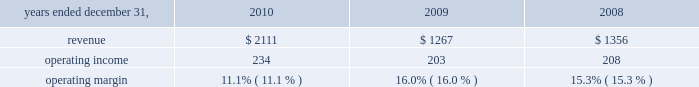Hr solutions .
In october 2010 , we completed the acquisition of hewitt , one of the world 2019s leading human resource consulting and outsourcing companies .
Hewitt operates globally together with aon 2019s existing consulting and outsourcing operations under the newly created aon hewitt brand .
Hewitt 2019s operating results are included in aon 2019s results of operations beginning october 1 , 2010 .
Our hr solutions segment generated approximately 25% ( 25 % ) of our consolidated total revenues in 2010 and provides a broad range of human capital services , as follows : consulting services : 2022 health and benefits advises clients about how to structure , fund , and administer employee benefit programs that attract , retain , and motivate employees .
Benefits consulting includes health and welfare , executive benefits , workforce strategies and productivity , absence management , benefits administration , data-driven health , compliance , employee commitment , investment advisory and elective benefits services .
2022 retirement specializes in global actuarial services , defined contribution consulting , investment consulting , tax and erisa consulting , and pension administration .
2022 compensation focuses on compensatory advisory/counsel including : compensation planning design , executive reward strategies , salary survey and benchmarking , market share studies and sales force effectiveness , with special expertise in the financial services and technology industries .
2022 strategic human capital delivers advice to complex global organizations on talent , change and organizational effectiveness issues , including talent strategy and acquisition , executive on-boarding , performance management , leadership assessment and development , communication strategy , workforce training and change management .
Outsourcing services : 2022 benefits outsourcing applies our hr expertise primarily through defined benefit ( pension ) , defined contribution ( 401 ( k ) ) , and health and welfare administrative services .
Our model replaces the resource-intensive processes once required to administer benefit plans with more efficient , effective , and less costly solutions .
2022 human resource business processing outsourcing ( 2018 2018hr bpo 2019 2019 ) provides market-leading solutions to manage employee data ; administer benefits , payroll and other human resources processes ; and record and manage talent , workforce and other core hr process transactions as well as other complementary services such as absence management , flexible spending , dependent audit and participant advocacy .
Beginning in late 2008 , the disruption in the global credit markets and the deterioration of the financial markets created significant uncertainty in the marketplace .
Weak economic conditions globally continued throughout 2010 .
The prolonged economic downturn is adversely impacting our clients 2019 financial condition and therefore the levels of business activities in the industries and geographies where we operate .
While we believe that the majority of our practices are well positioned to manage through this time , these challenges are reducing demand for some of our services and putting .
If hr solutions generated 25% ( 25 % ) of total revenues , what are the total revenue for aon in 2010 , ( in millions ) ? 
Computations: (2111 / 25%)
Answer: 8444.0. Hr solutions .
In october 2010 , we completed the acquisition of hewitt , one of the world 2019s leading human resource consulting and outsourcing companies .
Hewitt operates globally together with aon 2019s existing consulting and outsourcing operations under the newly created aon hewitt brand .
Hewitt 2019s operating results are included in aon 2019s results of operations beginning october 1 , 2010 .
Our hr solutions segment generated approximately 25% ( 25 % ) of our consolidated total revenues in 2010 and provides a broad range of human capital services , as follows : consulting services : 2022 health and benefits advises clients about how to structure , fund , and administer employee benefit programs that attract , retain , and motivate employees .
Benefits consulting includes health and welfare , executive benefits , workforce strategies and productivity , absence management , benefits administration , data-driven health , compliance , employee commitment , investment advisory and elective benefits services .
2022 retirement specializes in global actuarial services , defined contribution consulting , investment consulting , tax and erisa consulting , and pension administration .
2022 compensation focuses on compensatory advisory/counsel including : compensation planning design , executive reward strategies , salary survey and benchmarking , market share studies and sales force effectiveness , with special expertise in the financial services and technology industries .
2022 strategic human capital delivers advice to complex global organizations on talent , change and organizational effectiveness issues , including talent strategy and acquisition , executive on-boarding , performance management , leadership assessment and development , communication strategy , workforce training and change management .
Outsourcing services : 2022 benefits outsourcing applies our hr expertise primarily through defined benefit ( pension ) , defined contribution ( 401 ( k ) ) , and health and welfare administrative services .
Our model replaces the resource-intensive processes once required to administer benefit plans with more efficient , effective , and less costly solutions .
2022 human resource business processing outsourcing ( 2018 2018hr bpo 2019 2019 ) provides market-leading solutions to manage employee data ; administer benefits , payroll and other human resources processes ; and record and manage talent , workforce and other core hr process transactions as well as other complementary services such as absence management , flexible spending , dependent audit and participant advocacy .
Beginning in late 2008 , the disruption in the global credit markets and the deterioration of the financial markets created significant uncertainty in the marketplace .
Weak economic conditions globally continued throughout 2010 .
The prolonged economic downturn is adversely impacting our clients 2019 financial condition and therefore the levels of business activities in the industries and geographies where we operate .
While we believe that the majority of our practices are well positioned to manage through this time , these challenges are reducing demand for some of our services and putting .
What is the growth rate in operating income of hr solutions from 2009 to 2010? 
Computations: ((234 - 203) / 203)
Answer: 0.15271. 